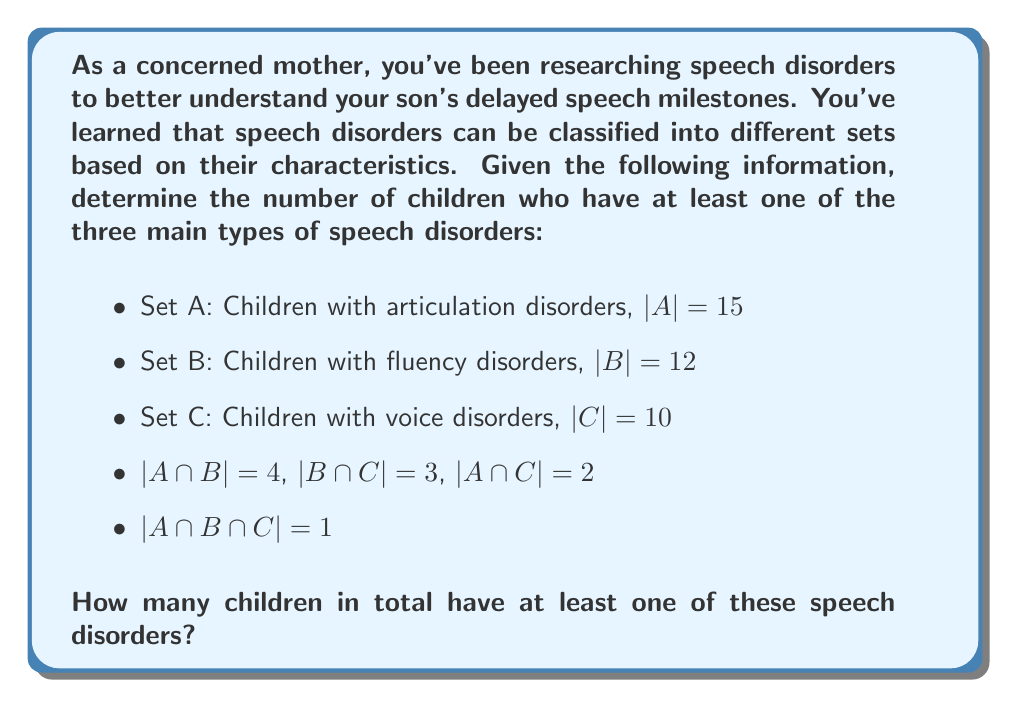Can you answer this question? To solve this problem, we'll use the Inclusion-Exclusion Principle from set theory. This principle allows us to calculate the number of elements in the union of multiple sets.

The formula for three sets is:

$$|A ∪ B ∪ C| = |A| + |B| + |C| - |A ∩ B| - |B ∩ C| - |A ∩ C| + |A ∩ B ∩ C|$$

Let's plug in the given values:

1. |A| = 15 (children with articulation disorders)
2. |B| = 12 (children with fluency disorders)
3. |C| = 10 (children with voice disorders)
4. |A ∩ B| = 4
5. |B ∩ C| = 3
6. |A ∩ C| = 2
7. |A ∩ B ∩ C| = 1

Now, let's substitute these values into the formula:

$$|A ∪ B ∪ C| = 15 + 12 + 10 - 4 - 3 - 2 + 1$$

Simplifying:

$$|A ∪ B ∪ C| = 37 - 9 + 1 = 29$$

Therefore, the total number of children who have at least one of these speech disorders is 29.
Answer: 29 children 